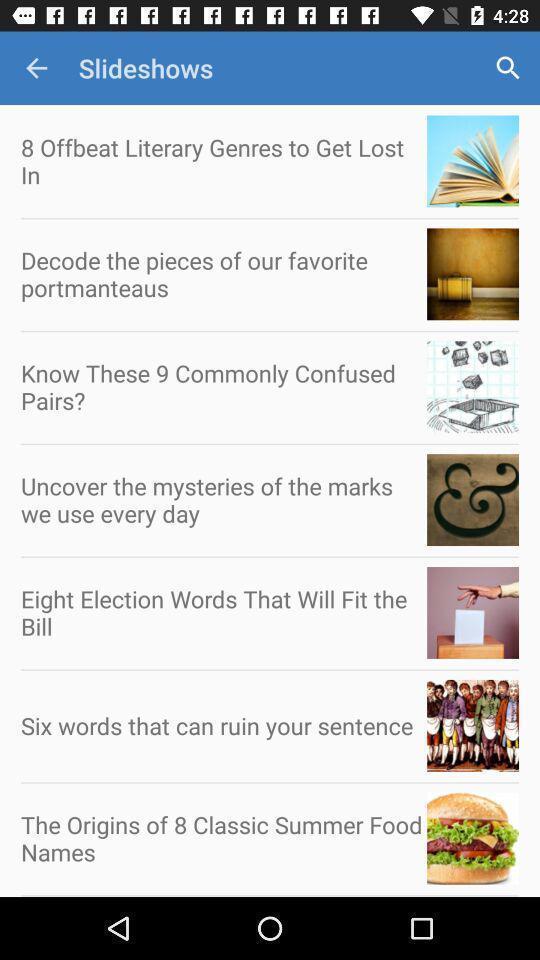What can you discern from this picture? Screen showing list of various categories of a learning app. 